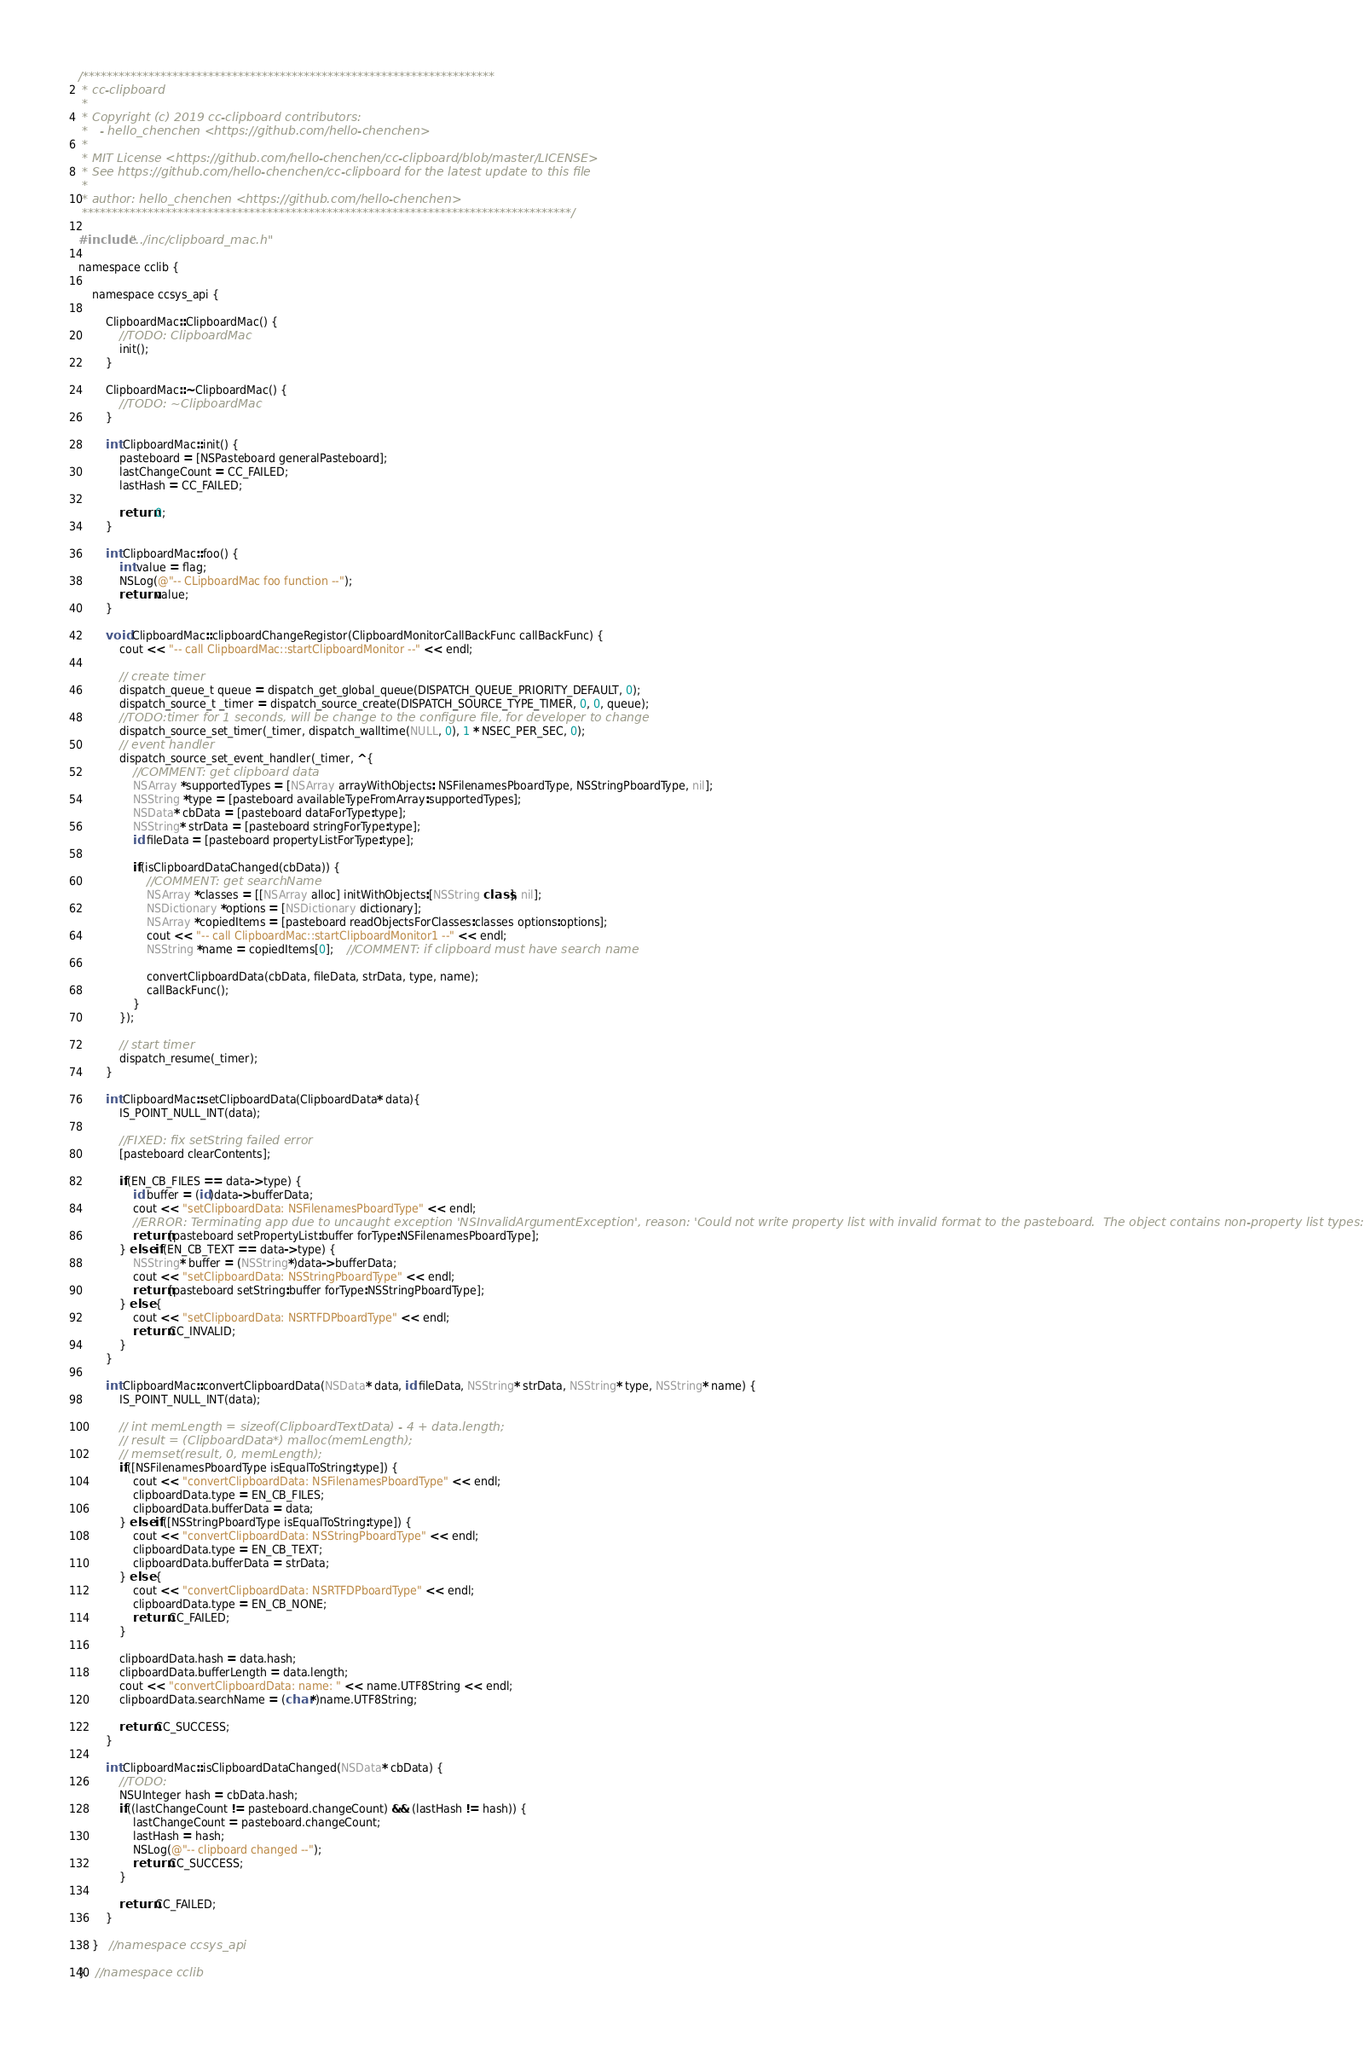<code> <loc_0><loc_0><loc_500><loc_500><_ObjectiveC_>/*********************************************************************
 * cc-clipboard
 *
 * Copyright (c) 2019 cc-clipboard contributors:
 *   - hello_chenchen <https://github.com/hello-chenchen>
 *
 * MIT License <https://github.com/hello-chenchen/cc-clipboard/blob/master/LICENSE>
 * See https://github.com/hello-chenchen/cc-clipboard for the latest update to this file
 *
 * author: hello_chenchen <https://github.com/hello-chenchen>
 **********************************************************************************/

#include "../inc/clipboard_mac.h"

namespace cclib {

    namespace ccsys_api {

        ClipboardMac::ClipboardMac() {
            //TODO: ClipboardMac
            init();
        }

        ClipboardMac::~ClipboardMac() {
            //TODO: ~ClipboardMac
        }

        int ClipboardMac::init() {
            pasteboard = [NSPasteboard generalPasteboard];
            lastChangeCount = CC_FAILED;
            lastHash = CC_FAILED;

            return 0;
        }

        int ClipboardMac::foo() {
            int value = flag;
            NSLog(@"-- CLipboardMac foo function --");
            return value;
        }

        void ClipboardMac::clipboardChangeRegistor(ClipboardMonitorCallBackFunc callBackFunc) {
            cout << "-- call ClipboardMac::startClipboardMonitor --" << endl;

            // create timer
            dispatch_queue_t queue = dispatch_get_global_queue(DISPATCH_QUEUE_PRIORITY_DEFAULT, 0);
            dispatch_source_t _timer = dispatch_source_create(DISPATCH_SOURCE_TYPE_TIMER, 0, 0, queue);
            //TODO:timer for 1 seconds, will be change to the configure file, for developer to change
            dispatch_source_set_timer(_timer, dispatch_walltime(NULL, 0), 1 * NSEC_PER_SEC, 0);
            // event handler
            dispatch_source_set_event_handler(_timer, ^{
                //COMMENT: get clipboard data
                NSArray *supportedTypes = [NSArray arrayWithObjects: NSFilenamesPboardType, NSStringPboardType, nil];
                NSString *type = [pasteboard availableTypeFromArray:supportedTypes];
                NSData* cbData = [pasteboard dataForType:type];
                NSString* strData = [pasteboard stringForType:type];
                id fileData = [pasteboard propertyListForType:type];

                if(isClipboardDataChanged(cbData)) {
                    //COMMENT: get searchName
                    NSArray *classes = [[NSArray alloc] initWithObjects:[NSString class], nil];
                    NSDictionary *options = [NSDictionary dictionary];
                    NSArray *copiedItems = [pasteboard readObjectsForClasses:classes options:options];
                    cout << "-- call ClipboardMac::startClipboardMonitor1 --" << endl;
                    NSString *name = copiedItems[0];    //COMMENT: if clipboard must have search name

                    convertClipboardData(cbData, fileData, strData, type, name);
                    callBackFunc();
                }
            });

            // start timer
            dispatch_resume(_timer);
        }

        int ClipboardMac::setClipboardData(ClipboardData* data){
            IS_POINT_NULL_INT(data);

            //FIXED: fix setString failed error
            [pasteboard clearContents];

            if(EN_CB_FILES == data->type) {
                id buffer = (id)data->bufferData;
                cout << "setClipboardData: NSFilenamesPboardType" << endl;
                //ERROR: Terminating app due to uncaught exception 'NSInvalidArgumentException', reason: 'Could not write property list with invalid format to the pasteboard.  The object contains non-property list types: __NSSetM'
                return [pasteboard setPropertyList:buffer forType:NSFilenamesPboardType];
            } else if(EN_CB_TEXT == data->type) {
                NSString* buffer = (NSString*)data->bufferData;
                cout << "setClipboardData: NSStringPboardType" << endl;
                return [pasteboard setString:buffer forType:NSStringPboardType];
            } else {
                cout << "setClipboardData: NSRTFDPboardType" << endl;
                return CC_INVALID;
            }
        }

        int ClipboardMac::convertClipboardData(NSData* data, id fileData, NSString* strData, NSString* type, NSString* name) {
            IS_POINT_NULL_INT(data);

            // int memLength = sizeof(ClipboardTextData) - 4 + data.length;
            // result = (ClipboardData*) malloc(memLength);
            // memset(result, 0, memLength);
            if([NSFilenamesPboardType isEqualToString:type]) {
                cout << "convertClipboardData: NSFilenamesPboardType" << endl;
                clipboardData.type = EN_CB_FILES;
                clipboardData.bufferData = data;
            } else if([NSStringPboardType isEqualToString:type]) {
                cout << "convertClipboardData: NSStringPboardType" << endl;
                clipboardData.type = EN_CB_TEXT;
                clipboardData.bufferData = strData;
            } else {
                cout << "convertClipboardData: NSRTFDPboardType" << endl;
                clipboardData.type = EN_CB_NONE;
                return CC_FAILED;
            }

            clipboardData.hash = data.hash;
            clipboardData.bufferLength = data.length;
            cout << "convertClipboardData: name: " << name.UTF8String << endl;
            clipboardData.searchName = (char*)name.UTF8String;

            return CC_SUCCESS;
        }

        int ClipboardMac::isClipboardDataChanged(NSData* cbData) {
            //TODO:
            NSUInteger hash = cbData.hash;
            if((lastChangeCount != pasteboard.changeCount) && (lastHash != hash)) {
                lastChangeCount = pasteboard.changeCount;
                lastHash = hash;
                NSLog(@"-- clipboard changed --");
                return CC_SUCCESS;
            }

            return CC_FAILED;
        }

    }   //namespace ccsys_api

}   //namespace cclib
</code> 